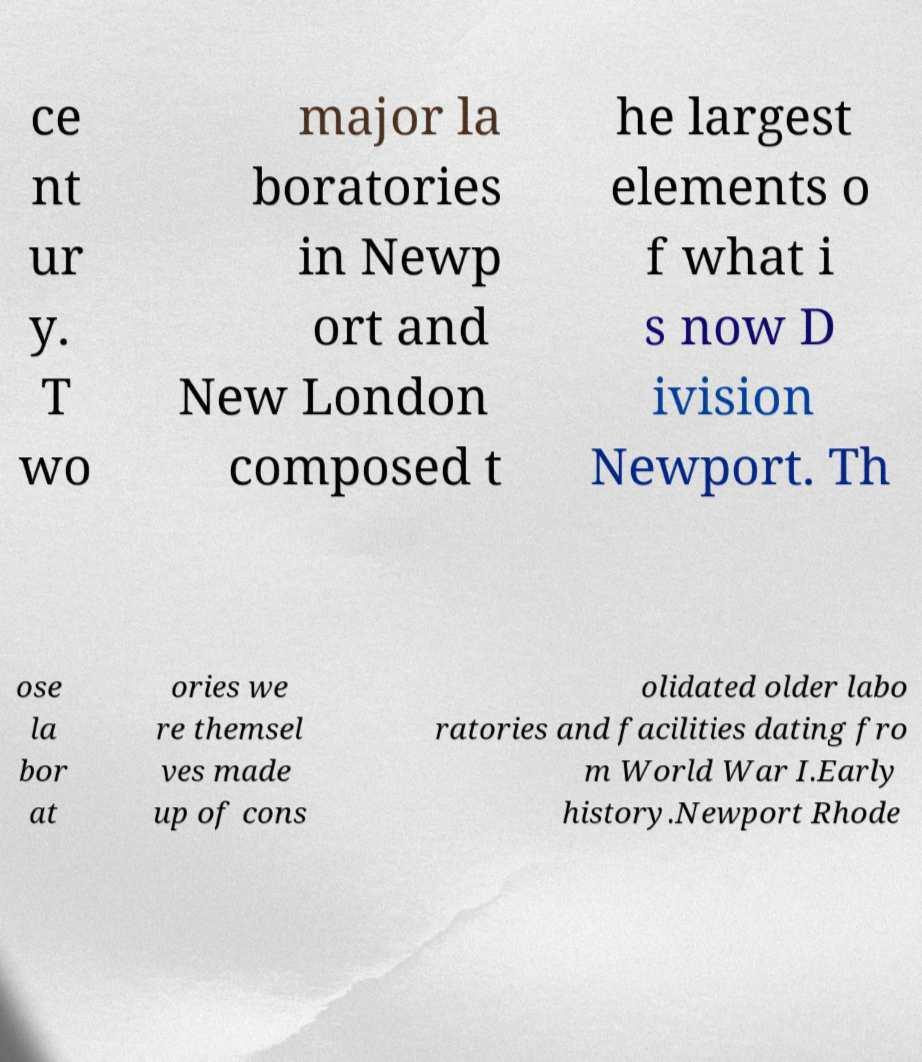Please read and relay the text visible in this image. What does it say? ce nt ur y. T wo major la boratories in Newp ort and New London composed t he largest elements o f what i s now D ivision Newport. Th ose la bor at ories we re themsel ves made up of cons olidated older labo ratories and facilities dating fro m World War I.Early history.Newport Rhode 